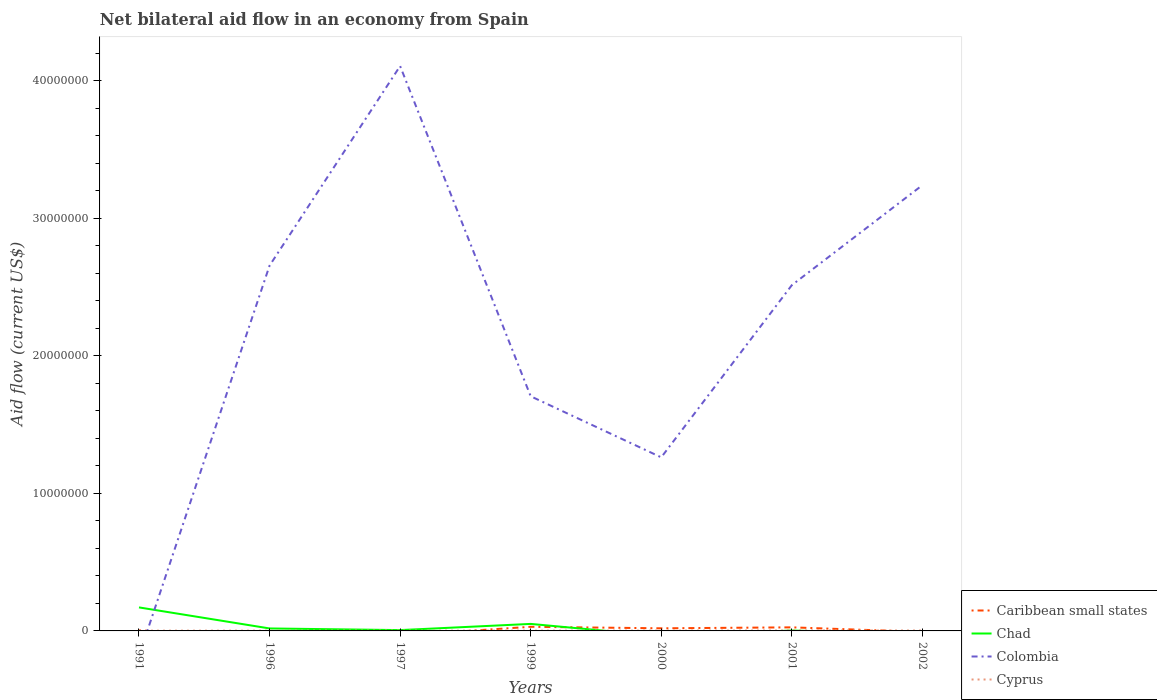Does the line corresponding to Cyprus intersect with the line corresponding to Chad?
Your answer should be very brief. Yes. What is the total net bilateral aid flow in Colombia in the graph?
Offer a terse response. -1.45e+07. What is the difference between the highest and the second highest net bilateral aid flow in Caribbean small states?
Keep it short and to the point. 3.00e+05. What is the difference between two consecutive major ticks on the Y-axis?
Provide a succinct answer. 1.00e+07. Are the values on the major ticks of Y-axis written in scientific E-notation?
Keep it short and to the point. No. Does the graph contain any zero values?
Your answer should be very brief. Yes. Where does the legend appear in the graph?
Your answer should be compact. Bottom right. How many legend labels are there?
Your answer should be compact. 4. How are the legend labels stacked?
Offer a terse response. Vertical. What is the title of the graph?
Your response must be concise. Net bilateral aid flow in an economy from Spain. What is the label or title of the Y-axis?
Give a very brief answer. Aid flow (current US$). What is the Aid flow (current US$) in Chad in 1991?
Your answer should be very brief. 1.71e+06. What is the Aid flow (current US$) in Caribbean small states in 1996?
Give a very brief answer. 0. What is the Aid flow (current US$) in Colombia in 1996?
Provide a succinct answer. 2.66e+07. What is the Aid flow (current US$) of Cyprus in 1996?
Offer a very short reply. 2.00e+04. What is the Aid flow (current US$) in Colombia in 1997?
Keep it short and to the point. 4.11e+07. What is the Aid flow (current US$) of Caribbean small states in 1999?
Your response must be concise. 3.00e+05. What is the Aid flow (current US$) of Chad in 1999?
Provide a succinct answer. 5.10e+05. What is the Aid flow (current US$) in Colombia in 1999?
Offer a terse response. 1.71e+07. What is the Aid flow (current US$) of Chad in 2000?
Give a very brief answer. 0. What is the Aid flow (current US$) of Colombia in 2000?
Make the answer very short. 1.26e+07. What is the Aid flow (current US$) in Cyprus in 2000?
Ensure brevity in your answer.  2.00e+04. What is the Aid flow (current US$) of Caribbean small states in 2001?
Your answer should be compact. 2.60e+05. What is the Aid flow (current US$) in Chad in 2001?
Your response must be concise. 3.00e+04. What is the Aid flow (current US$) in Colombia in 2001?
Your answer should be very brief. 2.51e+07. What is the Aid flow (current US$) in Cyprus in 2001?
Offer a very short reply. 3.00e+04. What is the Aid flow (current US$) in Caribbean small states in 2002?
Give a very brief answer. 0. What is the Aid flow (current US$) in Colombia in 2002?
Make the answer very short. 3.24e+07. Across all years, what is the maximum Aid flow (current US$) of Caribbean small states?
Give a very brief answer. 3.00e+05. Across all years, what is the maximum Aid flow (current US$) in Chad?
Your answer should be very brief. 1.71e+06. Across all years, what is the maximum Aid flow (current US$) in Colombia?
Your answer should be very brief. 4.11e+07. Across all years, what is the minimum Aid flow (current US$) of Chad?
Give a very brief answer. 0. Across all years, what is the minimum Aid flow (current US$) of Colombia?
Ensure brevity in your answer.  0. Across all years, what is the minimum Aid flow (current US$) in Cyprus?
Your answer should be very brief. 2.00e+04. What is the total Aid flow (current US$) of Caribbean small states in the graph?
Provide a short and direct response. 7.90e+05. What is the total Aid flow (current US$) in Chad in the graph?
Provide a short and direct response. 2.49e+06. What is the total Aid flow (current US$) of Colombia in the graph?
Your answer should be very brief. 1.55e+08. What is the difference between the Aid flow (current US$) in Chad in 1991 and that in 1996?
Your response must be concise. 1.53e+06. What is the difference between the Aid flow (current US$) in Chad in 1991 and that in 1997?
Offer a very short reply. 1.65e+06. What is the difference between the Aid flow (current US$) of Cyprus in 1991 and that in 1997?
Your answer should be very brief. 0. What is the difference between the Aid flow (current US$) in Caribbean small states in 1991 and that in 1999?
Ensure brevity in your answer.  -2.60e+05. What is the difference between the Aid flow (current US$) in Chad in 1991 and that in 1999?
Provide a succinct answer. 1.20e+06. What is the difference between the Aid flow (current US$) in Chad in 1991 and that in 2001?
Offer a terse response. 1.68e+06. What is the difference between the Aid flow (current US$) in Cyprus in 1991 and that in 2002?
Your answer should be compact. -10000. What is the difference between the Aid flow (current US$) in Chad in 1996 and that in 1997?
Provide a short and direct response. 1.20e+05. What is the difference between the Aid flow (current US$) in Colombia in 1996 and that in 1997?
Ensure brevity in your answer.  -1.45e+07. What is the difference between the Aid flow (current US$) of Cyprus in 1996 and that in 1997?
Provide a succinct answer. 0. What is the difference between the Aid flow (current US$) in Chad in 1996 and that in 1999?
Offer a terse response. -3.30e+05. What is the difference between the Aid flow (current US$) in Colombia in 1996 and that in 1999?
Provide a succinct answer. 9.50e+06. What is the difference between the Aid flow (current US$) of Colombia in 1996 and that in 2000?
Give a very brief answer. 1.39e+07. What is the difference between the Aid flow (current US$) in Chad in 1996 and that in 2001?
Give a very brief answer. 1.50e+05. What is the difference between the Aid flow (current US$) in Colombia in 1996 and that in 2001?
Give a very brief answer. 1.42e+06. What is the difference between the Aid flow (current US$) of Colombia in 1996 and that in 2002?
Give a very brief answer. -5.85e+06. What is the difference between the Aid flow (current US$) of Chad in 1997 and that in 1999?
Your response must be concise. -4.50e+05. What is the difference between the Aid flow (current US$) in Colombia in 1997 and that in 1999?
Give a very brief answer. 2.40e+07. What is the difference between the Aid flow (current US$) of Cyprus in 1997 and that in 1999?
Provide a succinct answer. 0. What is the difference between the Aid flow (current US$) of Colombia in 1997 and that in 2000?
Your answer should be compact. 2.84e+07. What is the difference between the Aid flow (current US$) of Cyprus in 1997 and that in 2000?
Offer a very short reply. 0. What is the difference between the Aid flow (current US$) in Colombia in 1997 and that in 2001?
Your answer should be very brief. 1.59e+07. What is the difference between the Aid flow (current US$) in Colombia in 1997 and that in 2002?
Ensure brevity in your answer.  8.66e+06. What is the difference between the Aid flow (current US$) in Caribbean small states in 1999 and that in 2000?
Ensure brevity in your answer.  1.10e+05. What is the difference between the Aid flow (current US$) of Colombia in 1999 and that in 2000?
Provide a short and direct response. 4.44e+06. What is the difference between the Aid flow (current US$) in Cyprus in 1999 and that in 2000?
Your answer should be very brief. 0. What is the difference between the Aid flow (current US$) of Colombia in 1999 and that in 2001?
Your answer should be very brief. -8.08e+06. What is the difference between the Aid flow (current US$) of Cyprus in 1999 and that in 2001?
Make the answer very short. -10000. What is the difference between the Aid flow (current US$) of Colombia in 1999 and that in 2002?
Offer a very short reply. -1.54e+07. What is the difference between the Aid flow (current US$) in Caribbean small states in 2000 and that in 2001?
Offer a terse response. -7.00e+04. What is the difference between the Aid flow (current US$) in Colombia in 2000 and that in 2001?
Provide a short and direct response. -1.25e+07. What is the difference between the Aid flow (current US$) of Colombia in 2000 and that in 2002?
Make the answer very short. -1.98e+07. What is the difference between the Aid flow (current US$) of Colombia in 2001 and that in 2002?
Offer a very short reply. -7.27e+06. What is the difference between the Aid flow (current US$) in Caribbean small states in 1991 and the Aid flow (current US$) in Chad in 1996?
Offer a very short reply. -1.40e+05. What is the difference between the Aid flow (current US$) in Caribbean small states in 1991 and the Aid flow (current US$) in Colombia in 1996?
Provide a short and direct response. -2.65e+07. What is the difference between the Aid flow (current US$) in Chad in 1991 and the Aid flow (current US$) in Colombia in 1996?
Provide a succinct answer. -2.48e+07. What is the difference between the Aid flow (current US$) in Chad in 1991 and the Aid flow (current US$) in Cyprus in 1996?
Give a very brief answer. 1.69e+06. What is the difference between the Aid flow (current US$) of Caribbean small states in 1991 and the Aid flow (current US$) of Colombia in 1997?
Ensure brevity in your answer.  -4.10e+07. What is the difference between the Aid flow (current US$) of Caribbean small states in 1991 and the Aid flow (current US$) of Cyprus in 1997?
Provide a short and direct response. 2.00e+04. What is the difference between the Aid flow (current US$) of Chad in 1991 and the Aid flow (current US$) of Colombia in 1997?
Your answer should be very brief. -3.94e+07. What is the difference between the Aid flow (current US$) in Chad in 1991 and the Aid flow (current US$) in Cyprus in 1997?
Your answer should be very brief. 1.69e+06. What is the difference between the Aid flow (current US$) of Caribbean small states in 1991 and the Aid flow (current US$) of Chad in 1999?
Your answer should be very brief. -4.70e+05. What is the difference between the Aid flow (current US$) of Caribbean small states in 1991 and the Aid flow (current US$) of Colombia in 1999?
Ensure brevity in your answer.  -1.70e+07. What is the difference between the Aid flow (current US$) in Caribbean small states in 1991 and the Aid flow (current US$) in Cyprus in 1999?
Your response must be concise. 2.00e+04. What is the difference between the Aid flow (current US$) of Chad in 1991 and the Aid flow (current US$) of Colombia in 1999?
Give a very brief answer. -1.54e+07. What is the difference between the Aid flow (current US$) of Chad in 1991 and the Aid flow (current US$) of Cyprus in 1999?
Offer a very short reply. 1.69e+06. What is the difference between the Aid flow (current US$) in Caribbean small states in 1991 and the Aid flow (current US$) in Colombia in 2000?
Make the answer very short. -1.26e+07. What is the difference between the Aid flow (current US$) in Chad in 1991 and the Aid flow (current US$) in Colombia in 2000?
Give a very brief answer. -1.09e+07. What is the difference between the Aid flow (current US$) in Chad in 1991 and the Aid flow (current US$) in Cyprus in 2000?
Ensure brevity in your answer.  1.69e+06. What is the difference between the Aid flow (current US$) of Caribbean small states in 1991 and the Aid flow (current US$) of Chad in 2001?
Make the answer very short. 10000. What is the difference between the Aid flow (current US$) in Caribbean small states in 1991 and the Aid flow (current US$) in Colombia in 2001?
Provide a succinct answer. -2.51e+07. What is the difference between the Aid flow (current US$) of Caribbean small states in 1991 and the Aid flow (current US$) of Cyprus in 2001?
Ensure brevity in your answer.  10000. What is the difference between the Aid flow (current US$) of Chad in 1991 and the Aid flow (current US$) of Colombia in 2001?
Offer a terse response. -2.34e+07. What is the difference between the Aid flow (current US$) in Chad in 1991 and the Aid flow (current US$) in Cyprus in 2001?
Offer a terse response. 1.68e+06. What is the difference between the Aid flow (current US$) in Caribbean small states in 1991 and the Aid flow (current US$) in Colombia in 2002?
Give a very brief answer. -3.24e+07. What is the difference between the Aid flow (current US$) of Chad in 1991 and the Aid flow (current US$) of Colombia in 2002?
Your answer should be very brief. -3.07e+07. What is the difference between the Aid flow (current US$) of Chad in 1991 and the Aid flow (current US$) of Cyprus in 2002?
Your answer should be very brief. 1.68e+06. What is the difference between the Aid flow (current US$) in Chad in 1996 and the Aid flow (current US$) in Colombia in 1997?
Your answer should be compact. -4.09e+07. What is the difference between the Aid flow (current US$) in Colombia in 1996 and the Aid flow (current US$) in Cyprus in 1997?
Give a very brief answer. 2.65e+07. What is the difference between the Aid flow (current US$) in Chad in 1996 and the Aid flow (current US$) in Colombia in 1999?
Your response must be concise. -1.69e+07. What is the difference between the Aid flow (current US$) of Colombia in 1996 and the Aid flow (current US$) of Cyprus in 1999?
Ensure brevity in your answer.  2.65e+07. What is the difference between the Aid flow (current US$) of Chad in 1996 and the Aid flow (current US$) of Colombia in 2000?
Offer a very short reply. -1.24e+07. What is the difference between the Aid flow (current US$) in Chad in 1996 and the Aid flow (current US$) in Cyprus in 2000?
Ensure brevity in your answer.  1.60e+05. What is the difference between the Aid flow (current US$) in Colombia in 1996 and the Aid flow (current US$) in Cyprus in 2000?
Your answer should be very brief. 2.65e+07. What is the difference between the Aid flow (current US$) of Chad in 1996 and the Aid flow (current US$) of Colombia in 2001?
Make the answer very short. -2.50e+07. What is the difference between the Aid flow (current US$) of Colombia in 1996 and the Aid flow (current US$) of Cyprus in 2001?
Ensure brevity in your answer.  2.65e+07. What is the difference between the Aid flow (current US$) in Chad in 1996 and the Aid flow (current US$) in Colombia in 2002?
Give a very brief answer. -3.22e+07. What is the difference between the Aid flow (current US$) of Chad in 1996 and the Aid flow (current US$) of Cyprus in 2002?
Offer a very short reply. 1.50e+05. What is the difference between the Aid flow (current US$) in Colombia in 1996 and the Aid flow (current US$) in Cyprus in 2002?
Offer a very short reply. 2.65e+07. What is the difference between the Aid flow (current US$) in Chad in 1997 and the Aid flow (current US$) in Colombia in 1999?
Provide a short and direct response. -1.70e+07. What is the difference between the Aid flow (current US$) of Colombia in 1997 and the Aid flow (current US$) of Cyprus in 1999?
Ensure brevity in your answer.  4.10e+07. What is the difference between the Aid flow (current US$) in Chad in 1997 and the Aid flow (current US$) in Colombia in 2000?
Provide a succinct answer. -1.26e+07. What is the difference between the Aid flow (current US$) in Chad in 1997 and the Aid flow (current US$) in Cyprus in 2000?
Offer a terse response. 4.00e+04. What is the difference between the Aid flow (current US$) of Colombia in 1997 and the Aid flow (current US$) of Cyprus in 2000?
Your answer should be very brief. 4.10e+07. What is the difference between the Aid flow (current US$) of Chad in 1997 and the Aid flow (current US$) of Colombia in 2001?
Give a very brief answer. -2.51e+07. What is the difference between the Aid flow (current US$) in Chad in 1997 and the Aid flow (current US$) in Cyprus in 2001?
Provide a short and direct response. 3.00e+04. What is the difference between the Aid flow (current US$) of Colombia in 1997 and the Aid flow (current US$) of Cyprus in 2001?
Your response must be concise. 4.10e+07. What is the difference between the Aid flow (current US$) of Chad in 1997 and the Aid flow (current US$) of Colombia in 2002?
Your answer should be very brief. -3.24e+07. What is the difference between the Aid flow (current US$) in Chad in 1997 and the Aid flow (current US$) in Cyprus in 2002?
Your response must be concise. 3.00e+04. What is the difference between the Aid flow (current US$) in Colombia in 1997 and the Aid flow (current US$) in Cyprus in 2002?
Your answer should be compact. 4.10e+07. What is the difference between the Aid flow (current US$) in Caribbean small states in 1999 and the Aid flow (current US$) in Colombia in 2000?
Provide a short and direct response. -1.23e+07. What is the difference between the Aid flow (current US$) of Chad in 1999 and the Aid flow (current US$) of Colombia in 2000?
Provide a succinct answer. -1.21e+07. What is the difference between the Aid flow (current US$) in Chad in 1999 and the Aid flow (current US$) in Cyprus in 2000?
Your answer should be very brief. 4.90e+05. What is the difference between the Aid flow (current US$) in Colombia in 1999 and the Aid flow (current US$) in Cyprus in 2000?
Your response must be concise. 1.70e+07. What is the difference between the Aid flow (current US$) of Caribbean small states in 1999 and the Aid flow (current US$) of Colombia in 2001?
Your response must be concise. -2.48e+07. What is the difference between the Aid flow (current US$) in Caribbean small states in 1999 and the Aid flow (current US$) in Cyprus in 2001?
Make the answer very short. 2.70e+05. What is the difference between the Aid flow (current US$) in Chad in 1999 and the Aid flow (current US$) in Colombia in 2001?
Provide a short and direct response. -2.46e+07. What is the difference between the Aid flow (current US$) in Colombia in 1999 and the Aid flow (current US$) in Cyprus in 2001?
Ensure brevity in your answer.  1.70e+07. What is the difference between the Aid flow (current US$) in Caribbean small states in 1999 and the Aid flow (current US$) in Colombia in 2002?
Give a very brief answer. -3.21e+07. What is the difference between the Aid flow (current US$) of Chad in 1999 and the Aid flow (current US$) of Colombia in 2002?
Your answer should be very brief. -3.19e+07. What is the difference between the Aid flow (current US$) of Colombia in 1999 and the Aid flow (current US$) of Cyprus in 2002?
Ensure brevity in your answer.  1.70e+07. What is the difference between the Aid flow (current US$) of Caribbean small states in 2000 and the Aid flow (current US$) of Chad in 2001?
Offer a very short reply. 1.60e+05. What is the difference between the Aid flow (current US$) of Caribbean small states in 2000 and the Aid flow (current US$) of Colombia in 2001?
Offer a very short reply. -2.50e+07. What is the difference between the Aid flow (current US$) of Caribbean small states in 2000 and the Aid flow (current US$) of Cyprus in 2001?
Offer a terse response. 1.60e+05. What is the difference between the Aid flow (current US$) in Colombia in 2000 and the Aid flow (current US$) in Cyprus in 2001?
Make the answer very short. 1.26e+07. What is the difference between the Aid flow (current US$) in Caribbean small states in 2000 and the Aid flow (current US$) in Colombia in 2002?
Ensure brevity in your answer.  -3.22e+07. What is the difference between the Aid flow (current US$) in Caribbean small states in 2000 and the Aid flow (current US$) in Cyprus in 2002?
Your response must be concise. 1.60e+05. What is the difference between the Aid flow (current US$) in Colombia in 2000 and the Aid flow (current US$) in Cyprus in 2002?
Make the answer very short. 1.26e+07. What is the difference between the Aid flow (current US$) in Caribbean small states in 2001 and the Aid flow (current US$) in Colombia in 2002?
Keep it short and to the point. -3.22e+07. What is the difference between the Aid flow (current US$) of Caribbean small states in 2001 and the Aid flow (current US$) of Cyprus in 2002?
Offer a very short reply. 2.30e+05. What is the difference between the Aid flow (current US$) in Chad in 2001 and the Aid flow (current US$) in Colombia in 2002?
Keep it short and to the point. -3.24e+07. What is the difference between the Aid flow (current US$) of Chad in 2001 and the Aid flow (current US$) of Cyprus in 2002?
Your answer should be compact. 0. What is the difference between the Aid flow (current US$) of Colombia in 2001 and the Aid flow (current US$) of Cyprus in 2002?
Keep it short and to the point. 2.51e+07. What is the average Aid flow (current US$) in Caribbean small states per year?
Keep it short and to the point. 1.13e+05. What is the average Aid flow (current US$) of Chad per year?
Give a very brief answer. 3.56e+05. What is the average Aid flow (current US$) in Colombia per year?
Your answer should be compact. 2.21e+07. What is the average Aid flow (current US$) of Cyprus per year?
Your answer should be compact. 2.29e+04. In the year 1991, what is the difference between the Aid flow (current US$) of Caribbean small states and Aid flow (current US$) of Chad?
Ensure brevity in your answer.  -1.67e+06. In the year 1991, what is the difference between the Aid flow (current US$) in Caribbean small states and Aid flow (current US$) in Cyprus?
Your answer should be very brief. 2.00e+04. In the year 1991, what is the difference between the Aid flow (current US$) of Chad and Aid flow (current US$) of Cyprus?
Your answer should be very brief. 1.69e+06. In the year 1996, what is the difference between the Aid flow (current US$) of Chad and Aid flow (current US$) of Colombia?
Ensure brevity in your answer.  -2.64e+07. In the year 1996, what is the difference between the Aid flow (current US$) in Colombia and Aid flow (current US$) in Cyprus?
Offer a very short reply. 2.65e+07. In the year 1997, what is the difference between the Aid flow (current US$) in Chad and Aid flow (current US$) in Colombia?
Your answer should be very brief. -4.10e+07. In the year 1997, what is the difference between the Aid flow (current US$) of Chad and Aid flow (current US$) of Cyprus?
Your answer should be very brief. 4.00e+04. In the year 1997, what is the difference between the Aid flow (current US$) of Colombia and Aid flow (current US$) of Cyprus?
Offer a very short reply. 4.10e+07. In the year 1999, what is the difference between the Aid flow (current US$) of Caribbean small states and Aid flow (current US$) of Chad?
Your response must be concise. -2.10e+05. In the year 1999, what is the difference between the Aid flow (current US$) in Caribbean small states and Aid flow (current US$) in Colombia?
Give a very brief answer. -1.68e+07. In the year 1999, what is the difference between the Aid flow (current US$) in Caribbean small states and Aid flow (current US$) in Cyprus?
Offer a very short reply. 2.80e+05. In the year 1999, what is the difference between the Aid flow (current US$) of Chad and Aid flow (current US$) of Colombia?
Make the answer very short. -1.66e+07. In the year 1999, what is the difference between the Aid flow (current US$) in Colombia and Aid flow (current US$) in Cyprus?
Your answer should be very brief. 1.70e+07. In the year 2000, what is the difference between the Aid flow (current US$) in Caribbean small states and Aid flow (current US$) in Colombia?
Give a very brief answer. -1.24e+07. In the year 2000, what is the difference between the Aid flow (current US$) of Colombia and Aid flow (current US$) of Cyprus?
Your answer should be very brief. 1.26e+07. In the year 2001, what is the difference between the Aid flow (current US$) of Caribbean small states and Aid flow (current US$) of Colombia?
Ensure brevity in your answer.  -2.49e+07. In the year 2001, what is the difference between the Aid flow (current US$) of Chad and Aid flow (current US$) of Colombia?
Provide a succinct answer. -2.51e+07. In the year 2001, what is the difference between the Aid flow (current US$) in Chad and Aid flow (current US$) in Cyprus?
Provide a short and direct response. 0. In the year 2001, what is the difference between the Aid flow (current US$) of Colombia and Aid flow (current US$) of Cyprus?
Provide a short and direct response. 2.51e+07. In the year 2002, what is the difference between the Aid flow (current US$) in Colombia and Aid flow (current US$) in Cyprus?
Your answer should be compact. 3.24e+07. What is the ratio of the Aid flow (current US$) of Chad in 1991 to that in 1996?
Ensure brevity in your answer.  9.5. What is the ratio of the Aid flow (current US$) of Caribbean small states in 1991 to that in 1999?
Your answer should be very brief. 0.13. What is the ratio of the Aid flow (current US$) of Chad in 1991 to that in 1999?
Give a very brief answer. 3.35. What is the ratio of the Aid flow (current US$) of Cyprus in 1991 to that in 1999?
Give a very brief answer. 1. What is the ratio of the Aid flow (current US$) in Caribbean small states in 1991 to that in 2000?
Offer a terse response. 0.21. What is the ratio of the Aid flow (current US$) in Caribbean small states in 1991 to that in 2001?
Keep it short and to the point. 0.15. What is the ratio of the Aid flow (current US$) in Chad in 1991 to that in 2001?
Provide a short and direct response. 57. What is the ratio of the Aid flow (current US$) of Cyprus in 1991 to that in 2001?
Your answer should be very brief. 0.67. What is the ratio of the Aid flow (current US$) of Cyprus in 1991 to that in 2002?
Offer a very short reply. 0.67. What is the ratio of the Aid flow (current US$) of Colombia in 1996 to that in 1997?
Provide a short and direct response. 0.65. What is the ratio of the Aid flow (current US$) of Chad in 1996 to that in 1999?
Offer a terse response. 0.35. What is the ratio of the Aid flow (current US$) in Colombia in 1996 to that in 1999?
Your response must be concise. 1.56. What is the ratio of the Aid flow (current US$) in Cyprus in 1996 to that in 1999?
Your answer should be compact. 1. What is the ratio of the Aid flow (current US$) in Colombia in 1996 to that in 2000?
Your response must be concise. 2.1. What is the ratio of the Aid flow (current US$) of Chad in 1996 to that in 2001?
Provide a short and direct response. 6. What is the ratio of the Aid flow (current US$) of Colombia in 1996 to that in 2001?
Give a very brief answer. 1.06. What is the ratio of the Aid flow (current US$) of Colombia in 1996 to that in 2002?
Offer a terse response. 0.82. What is the ratio of the Aid flow (current US$) in Cyprus in 1996 to that in 2002?
Your answer should be very brief. 0.67. What is the ratio of the Aid flow (current US$) of Chad in 1997 to that in 1999?
Provide a short and direct response. 0.12. What is the ratio of the Aid flow (current US$) of Colombia in 1997 to that in 1999?
Your answer should be compact. 2.41. What is the ratio of the Aid flow (current US$) of Cyprus in 1997 to that in 1999?
Offer a very short reply. 1. What is the ratio of the Aid flow (current US$) in Colombia in 1997 to that in 2000?
Your answer should be compact. 3.25. What is the ratio of the Aid flow (current US$) in Colombia in 1997 to that in 2001?
Offer a terse response. 1.63. What is the ratio of the Aid flow (current US$) in Cyprus in 1997 to that in 2001?
Your answer should be compact. 0.67. What is the ratio of the Aid flow (current US$) of Colombia in 1997 to that in 2002?
Give a very brief answer. 1.27. What is the ratio of the Aid flow (current US$) of Caribbean small states in 1999 to that in 2000?
Provide a short and direct response. 1.58. What is the ratio of the Aid flow (current US$) in Colombia in 1999 to that in 2000?
Provide a succinct answer. 1.35. What is the ratio of the Aid flow (current US$) in Cyprus in 1999 to that in 2000?
Keep it short and to the point. 1. What is the ratio of the Aid flow (current US$) in Caribbean small states in 1999 to that in 2001?
Your answer should be compact. 1.15. What is the ratio of the Aid flow (current US$) in Chad in 1999 to that in 2001?
Offer a very short reply. 17. What is the ratio of the Aid flow (current US$) of Colombia in 1999 to that in 2001?
Provide a succinct answer. 0.68. What is the ratio of the Aid flow (current US$) in Cyprus in 1999 to that in 2001?
Your answer should be very brief. 0.67. What is the ratio of the Aid flow (current US$) of Colombia in 1999 to that in 2002?
Offer a very short reply. 0.53. What is the ratio of the Aid flow (current US$) in Caribbean small states in 2000 to that in 2001?
Make the answer very short. 0.73. What is the ratio of the Aid flow (current US$) of Colombia in 2000 to that in 2001?
Ensure brevity in your answer.  0.5. What is the ratio of the Aid flow (current US$) of Colombia in 2000 to that in 2002?
Offer a very short reply. 0.39. What is the ratio of the Aid flow (current US$) in Cyprus in 2000 to that in 2002?
Keep it short and to the point. 0.67. What is the ratio of the Aid flow (current US$) of Colombia in 2001 to that in 2002?
Provide a short and direct response. 0.78. What is the ratio of the Aid flow (current US$) in Cyprus in 2001 to that in 2002?
Provide a succinct answer. 1. What is the difference between the highest and the second highest Aid flow (current US$) of Chad?
Provide a succinct answer. 1.20e+06. What is the difference between the highest and the second highest Aid flow (current US$) of Colombia?
Offer a very short reply. 8.66e+06. What is the difference between the highest and the second highest Aid flow (current US$) in Cyprus?
Provide a short and direct response. 0. What is the difference between the highest and the lowest Aid flow (current US$) in Chad?
Keep it short and to the point. 1.71e+06. What is the difference between the highest and the lowest Aid flow (current US$) in Colombia?
Make the answer very short. 4.11e+07. 